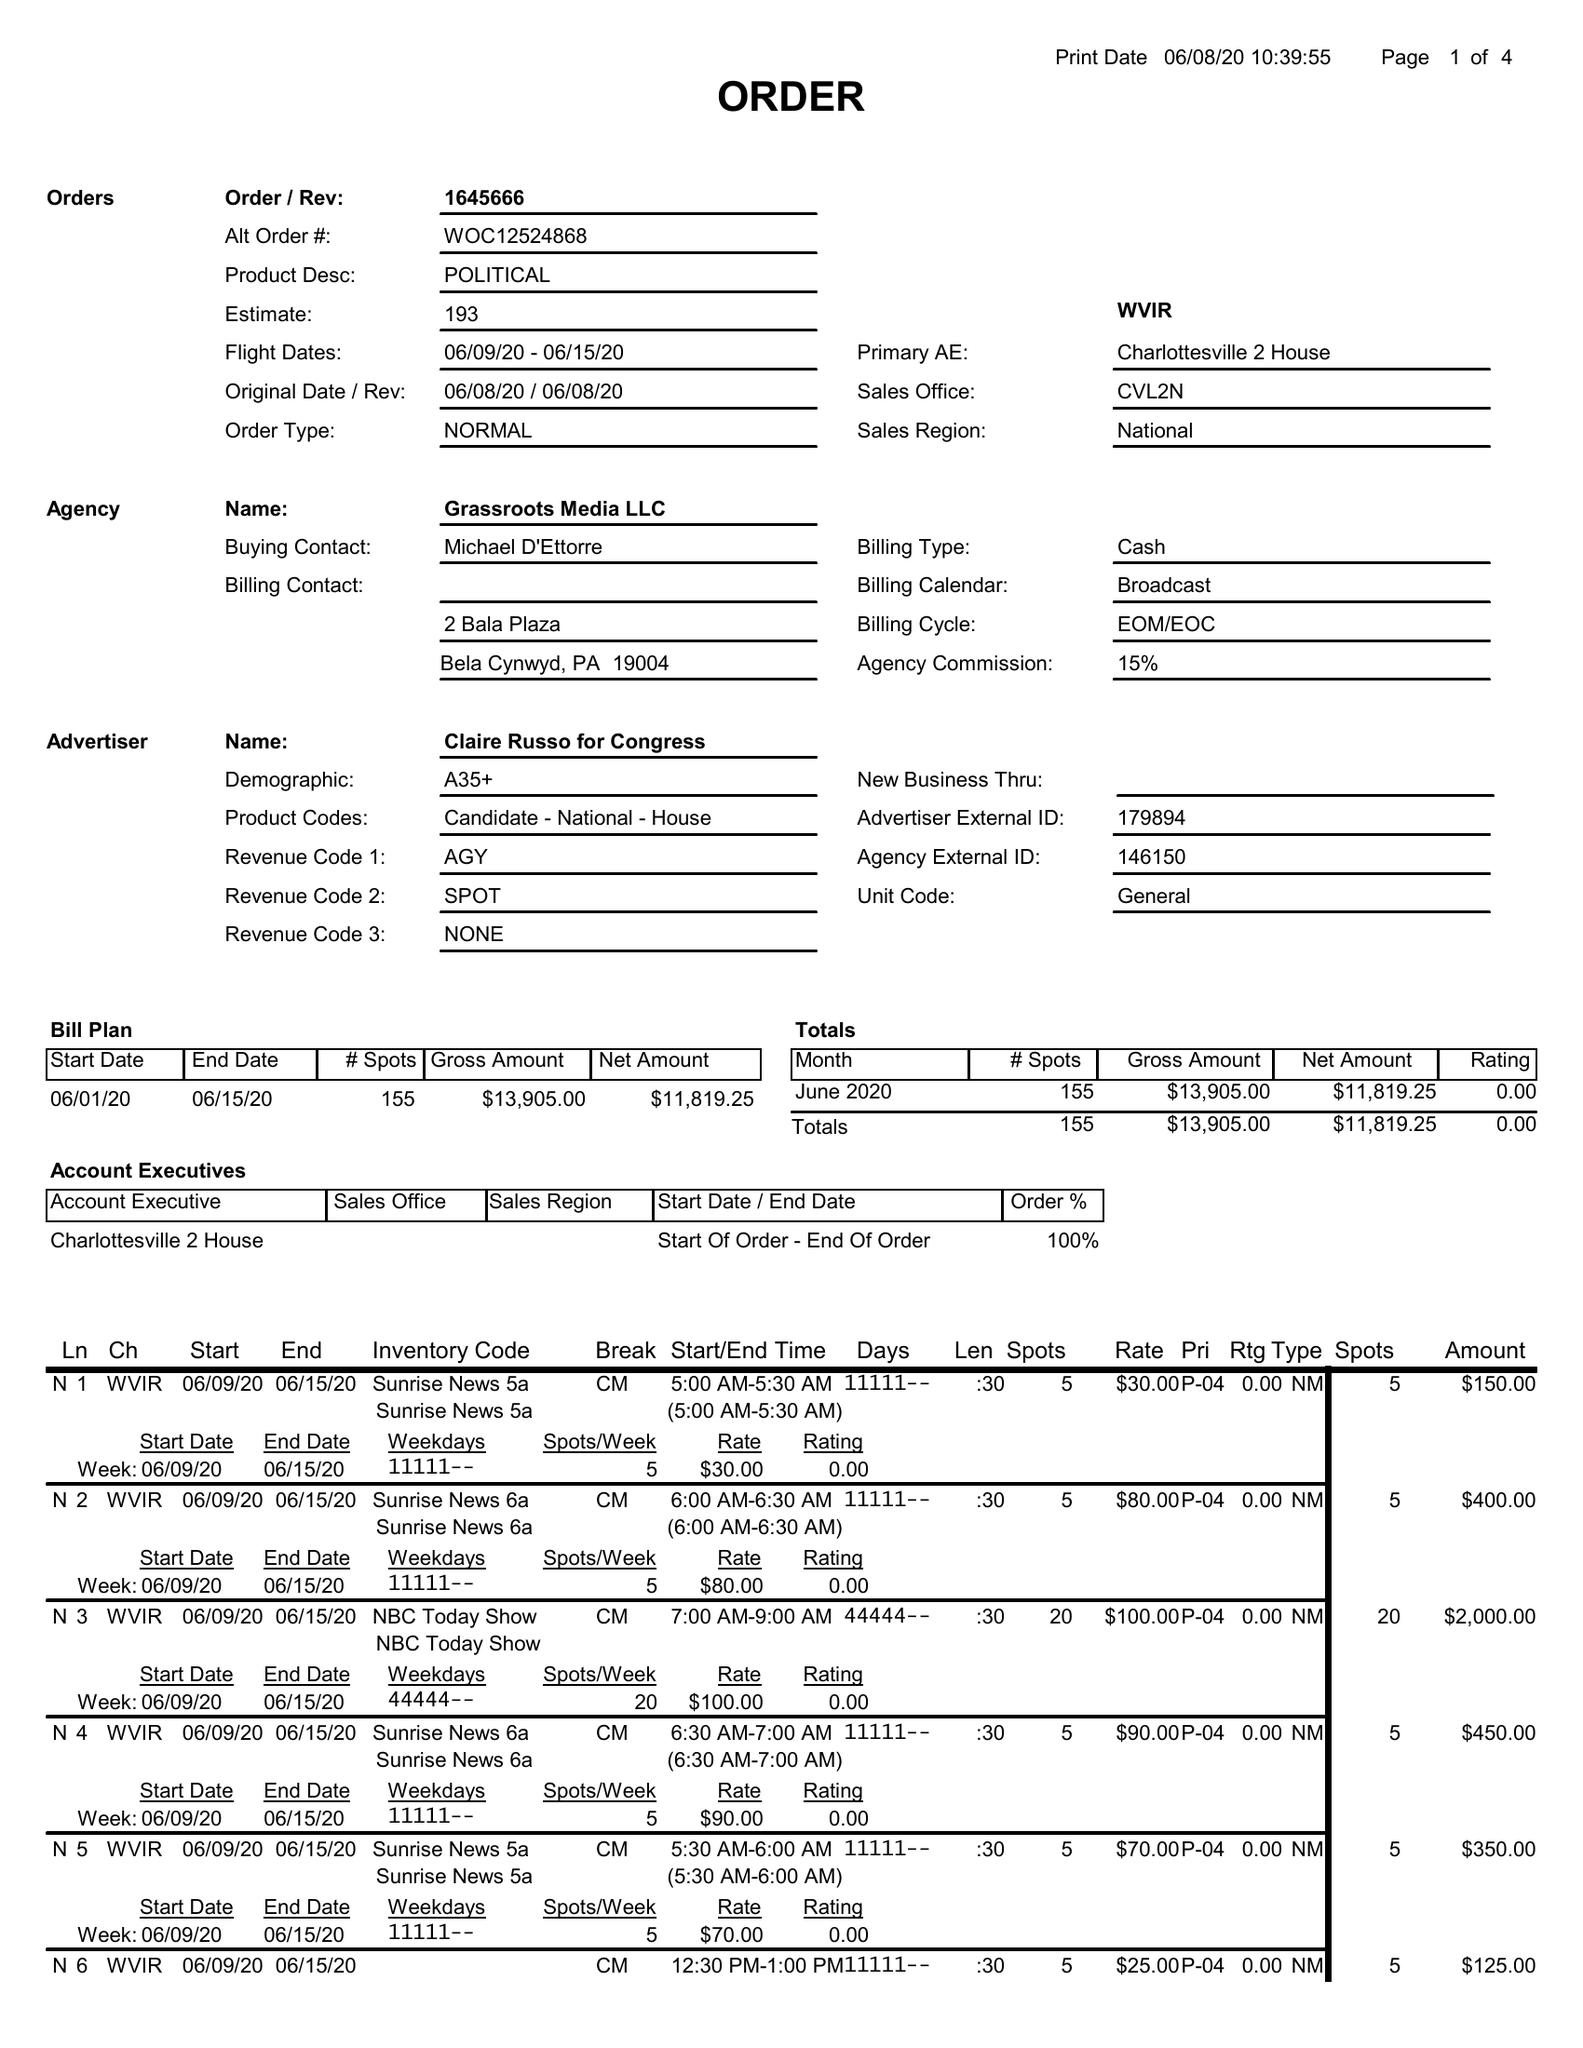What is the value for the gross_amount?
Answer the question using a single word or phrase. 13905.00 